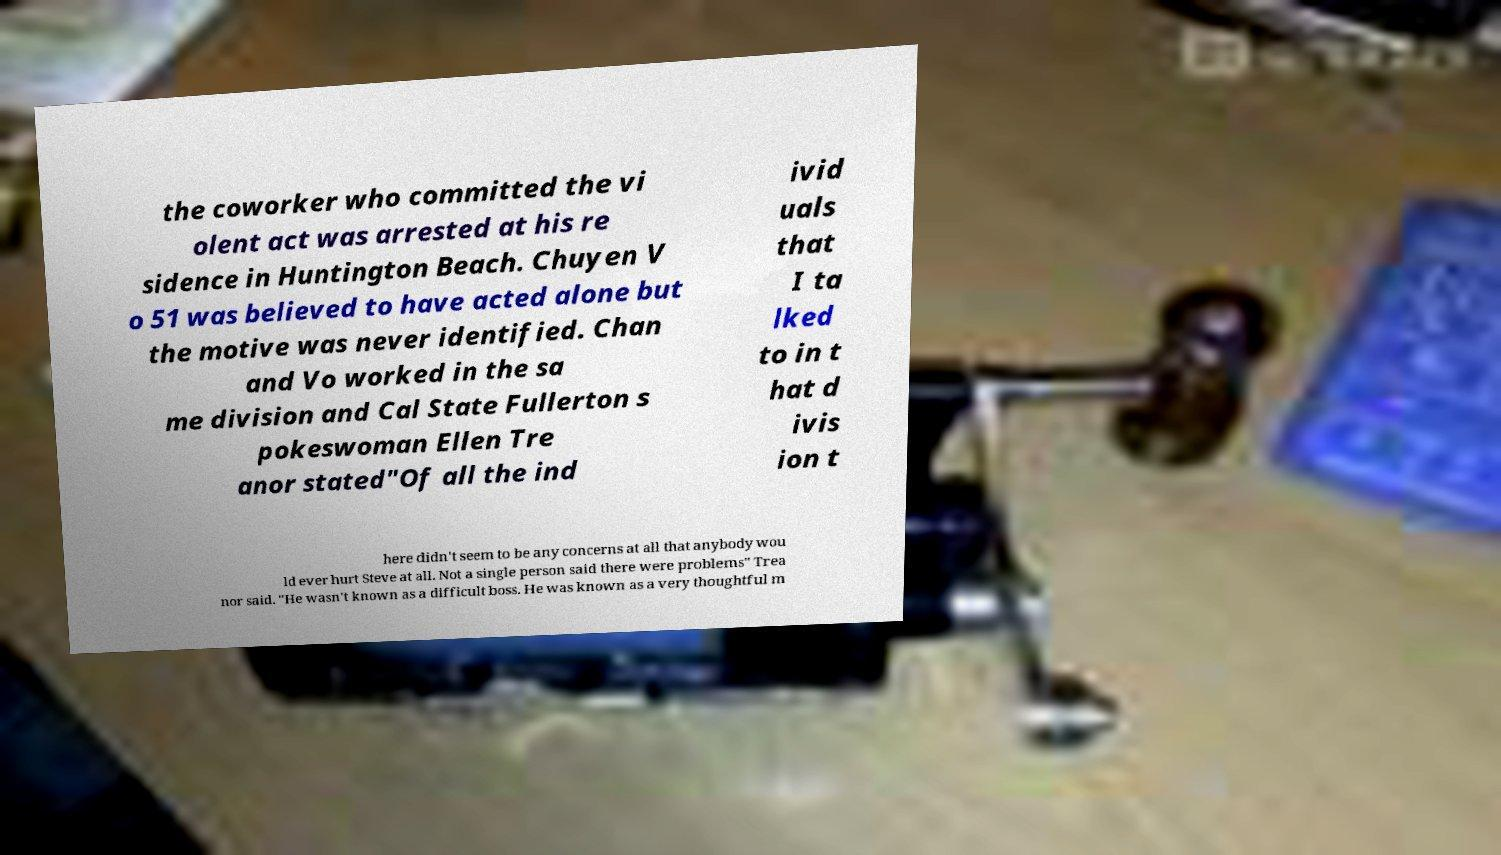Can you accurately transcribe the text from the provided image for me? the coworker who committed the vi olent act was arrested at his re sidence in Huntington Beach. Chuyen V o 51 was believed to have acted alone but the motive was never identified. Chan and Vo worked in the sa me division and Cal State Fullerton s pokeswoman Ellen Tre anor stated"Of all the ind ivid uals that I ta lked to in t hat d ivis ion t here didn't seem to be any concerns at all that anybody wou ld ever hurt Steve at all. Not a single person said there were problems" Trea nor said. "He wasn't known as a difficult boss. He was known as a very thoughtful m 